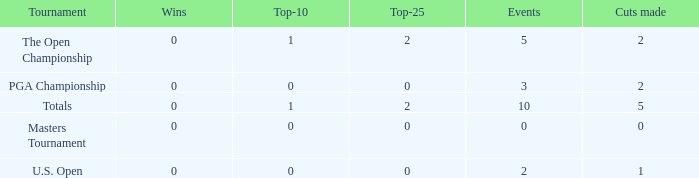What is the sum of top-10s for events with more than 0 wins? None. 